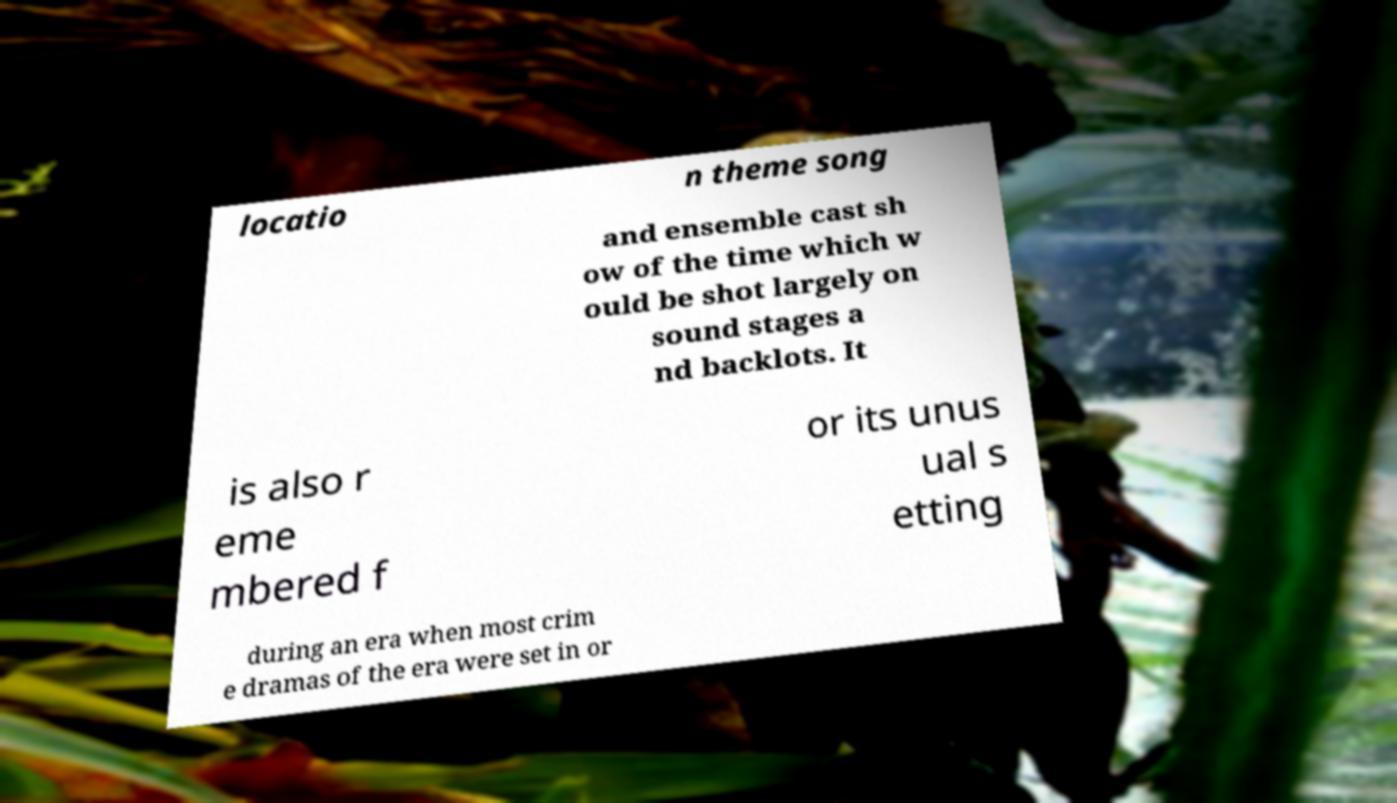Could you assist in decoding the text presented in this image and type it out clearly? locatio n theme song and ensemble cast sh ow of the time which w ould be shot largely on sound stages a nd backlots. It is also r eme mbered f or its unus ual s etting during an era when most crim e dramas of the era were set in or 